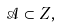<formula> <loc_0><loc_0><loc_500><loc_500>\mathcal { A } \subset Z ,</formula> 